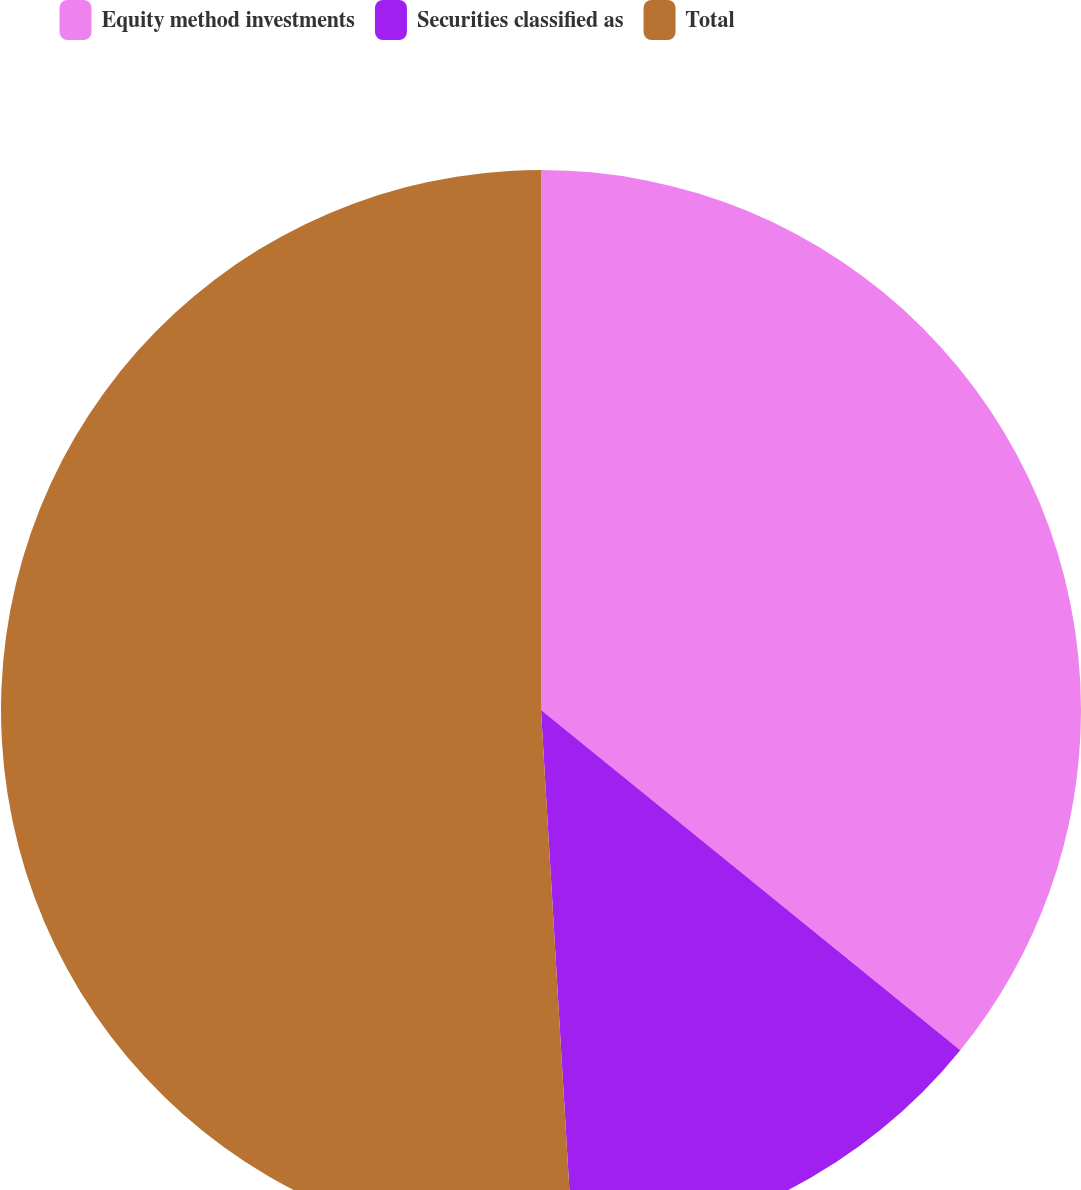Convert chart. <chart><loc_0><loc_0><loc_500><loc_500><pie_chart><fcel>Equity method investments<fcel>Securities classified as<fcel>Total<nl><fcel>35.85%<fcel>13.21%<fcel>50.94%<nl></chart> 